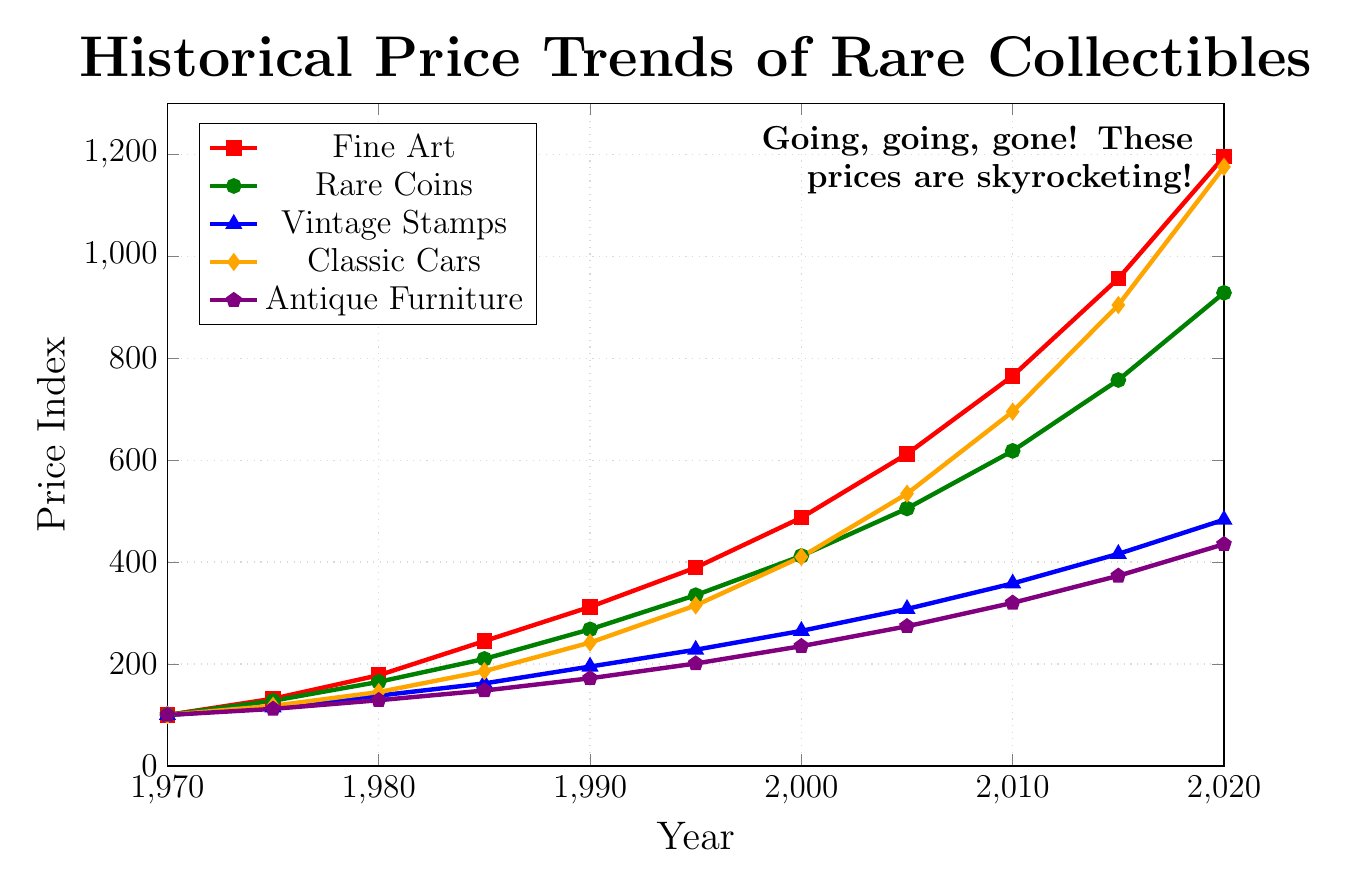what type of collectible showed the highest price increase from 1970 to 2020? Calculate the difference between prices in 2020 and 1970 for each collectible. Fine Art: 1195-100=1095, Rare Coins: 928-100=828, Vintage Stamps: 483-100=383, Classic Cars: 1175-100=1075, Antique Furniture: 435-100=335. Fine Art showed the highest price increase.
Answer: Fine Art Compare the price trends of Fine Art and Antique Furniture in 2020. Which one is higher and by how much? Fine Art in 2020 is 1195 and Antique Furniture is 435. The difference is 1195-435=760. Fine Art is higher by 760.
Answer: Fine Art by 760 In which decade did Classic Cars first overtake Rare Coins in price? Compare each decade’s prices; By 2000, Classic Cars (410) surpass Rare Coins (412) marginally; however, clear overtaking is evident by 2005: Classic Cars (534) vs. Rare Coins (505).
Answer: 2005 What type of collectible had the least growth in value from 1970 to 2020? Calculate the increase for each collectible from 1970 to 2020. Antique Furniture's growth is 435-100=335, which is the least compared to others.
Answer: Antique Furniture Between which years did Fine Art see the greatest incremental increase? Find the years with the highest price jump in Fine Art by checking consecutive increments. Fine Art shows the greatest increase between 2015-2020: 1195-956=239.
Answer: 2015-2020 How did the price of Vintage Stamps in 1995 compare with Classic Cars in the same year? Compare prices for 1995: Vintage Stamps are 228 and Classic Cars are 315, so Classic Cars were higher by 315-228=87.
Answer: Classic Cars by 87 What is the ratio of the price of Classic Cars to Rare Coins in 2020? Calculate the ratio of Classic Cars to Rare Coins prices in 2020. Classic Cars (1175) to Rare Coins (928): 1175/928 ≈ 1.27.
Answer: 1.27 Which type of collectible consistently increased in price every year without any decline? Observing the data from 1970 to 2020, Rare Coins, fine art, Classic Cars, and the other two categories increased consistently.
Answer: All collectibles What is the average price of Fine Art over the 50-year period? Sum up Fine Art prices over time and divide by 11 data points. i.e. (100+132+178+245+312+389+487+612+765+956+1195) = 5371, Average = 5371/11 ≈ 488.27.
Answer: 488.27 